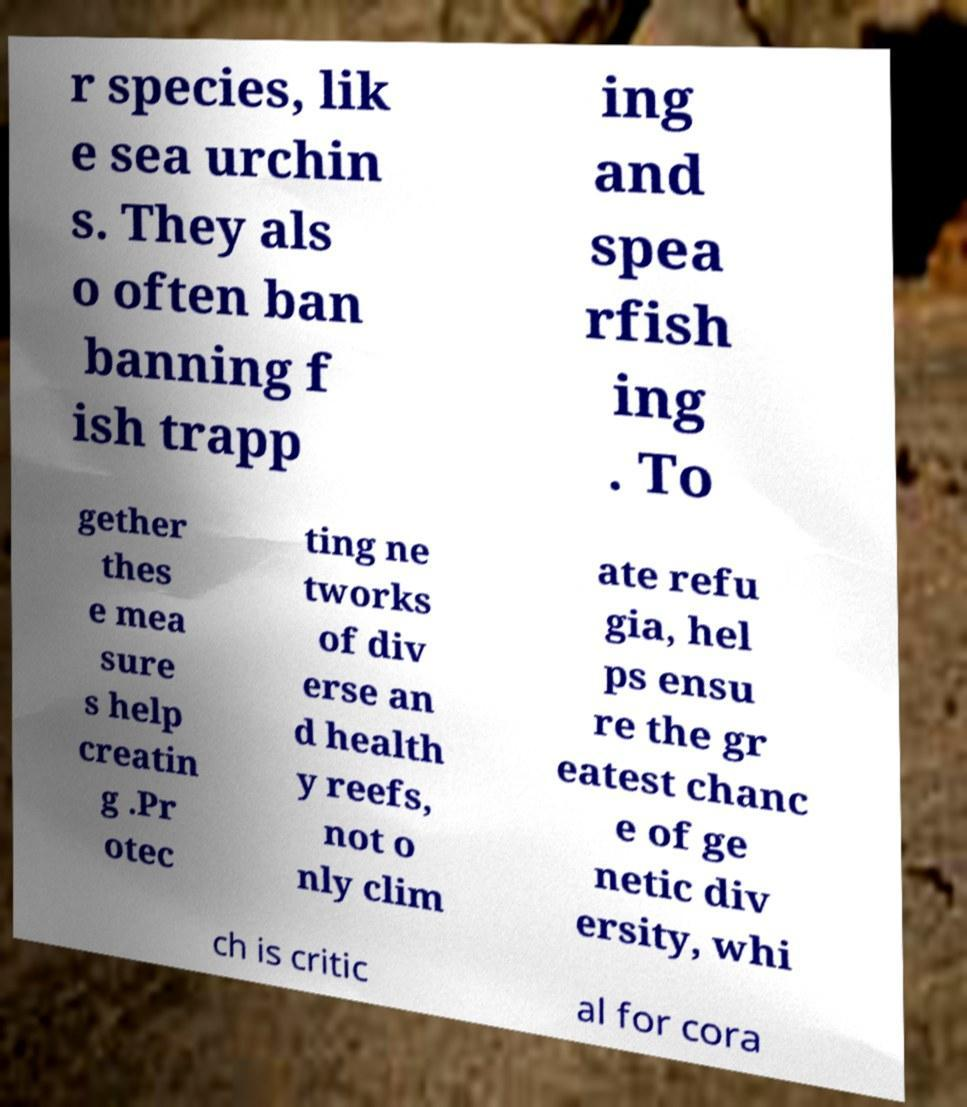Could you assist in decoding the text presented in this image and type it out clearly? r species, lik e sea urchin s. They als o often ban banning f ish trapp ing and spea rfish ing . To gether thes e mea sure s help creatin g .Pr otec ting ne tworks of div erse an d health y reefs, not o nly clim ate refu gia, hel ps ensu re the gr eatest chanc e of ge netic div ersity, whi ch is critic al for cora 